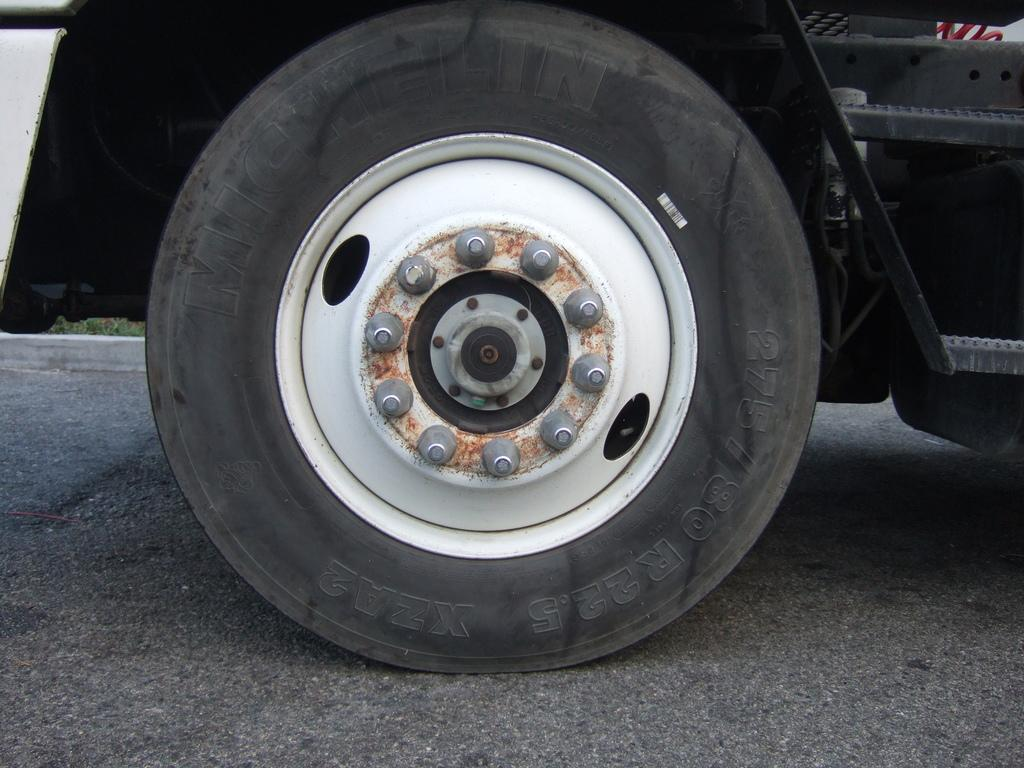What type of vehicle part is visible in the image? The image contains a part of a vehicle that includes a tire, rim, and nuts. Where is the vehicle part located? The vehicle part is parked on the road. What type of vase is being used to hold the skin in the competition in the image? There is no vase, skin, or competition present in the image; it only features a part of a vehicle parked on the road. 